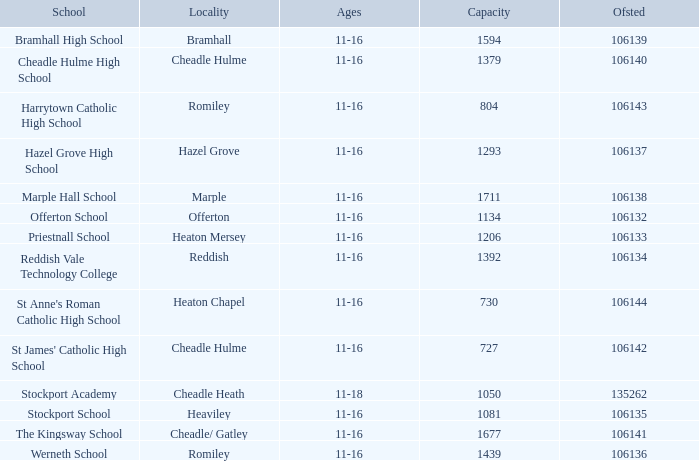In which ofsted can a total of 1677 persons be accommodated? 106141.0. 